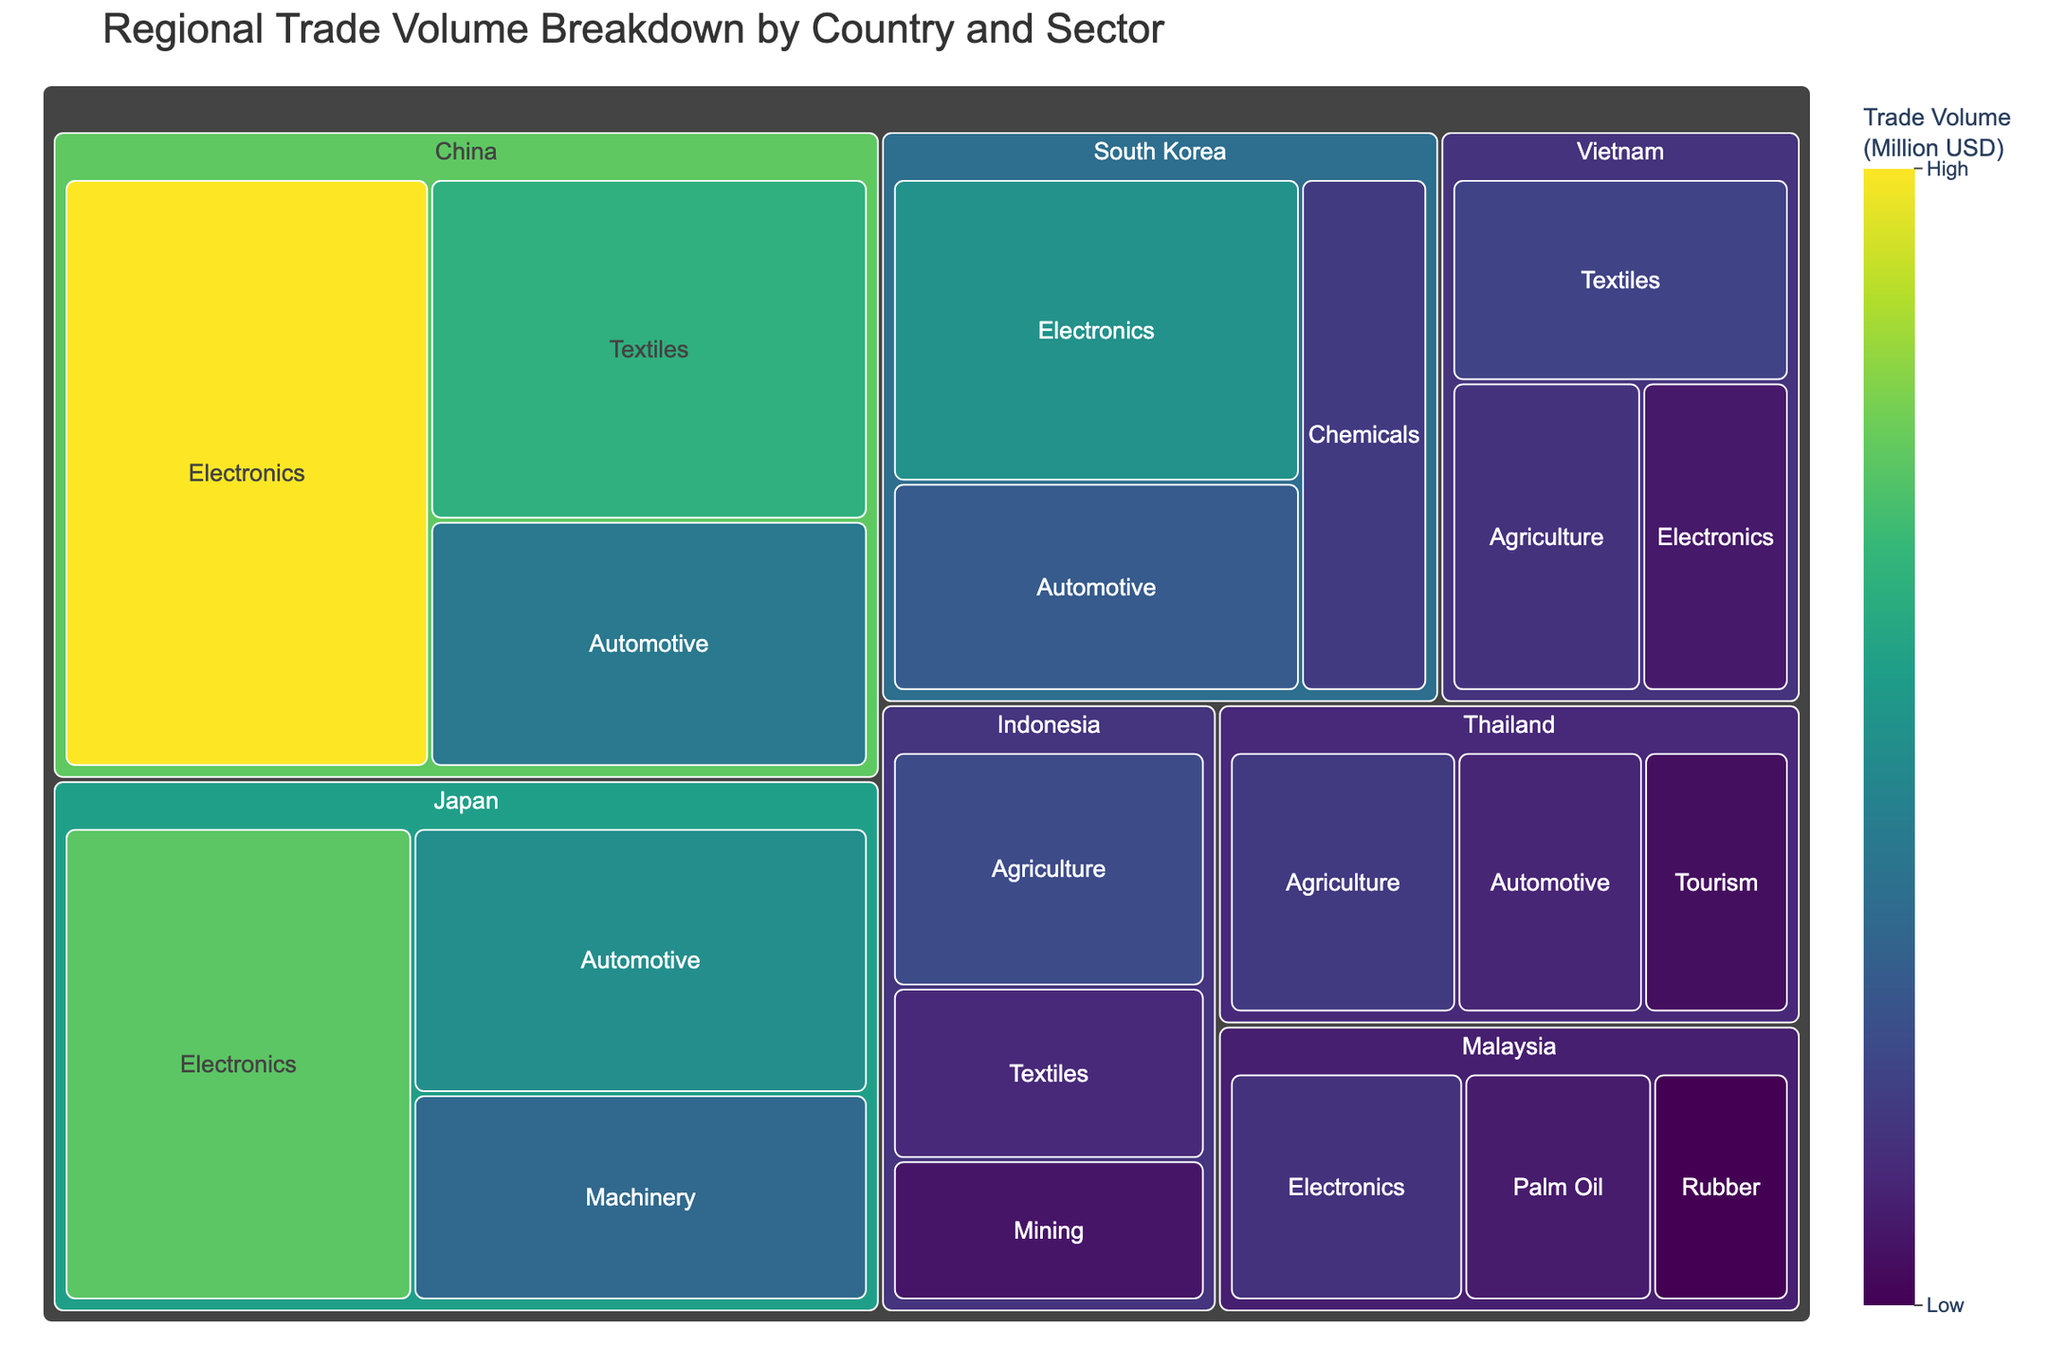what is the title of the figure? The title of the figure is usually placed at the top and clearly indicates the main subject. In this case, it reads "Regional Trade Volume Breakdown by Country and Sector".
Answer: Regional Trade Volume Breakdown by Country and Sector Which country has the highest trade volume in the Electronics sector? To determine this, look at the different segments under the Electronics category and identify the country with the largest segment. Here, China's Electronics sector has the highest trade volume.
Answer: China What is the total trade volume for Japan across all sectors? Sum the trade volumes for Japan's sectors: Electronics (9800) + Automotive (7200) + Machinery (5600). This gives a total trade volume.
Answer: 22600 Million USD Which sector has the smallest trade volume in Thailand? Look at all the sectors within Thailand's segments and compare their trade volumes. Tourism, with a volume of 2500 Million USD, is the smallest.
Answer: Tourism How does South Korea's trade volume in the Chemicals sector compare with Vietnam's trade volume in Textiles? Look at the trade volumes for both sectors: South Korea's Chemicals sector is 3900 Million USD and Vietnam's Textiles sector is 4200 Million USD. Vietnam's volume is higher.
Answer: Vietnam's volume is higher What is the difference in trade volume between China's Automotive sector and Japan's Automotive sector? Subtract Japan's Automotive trade volume (7200) from China's Automotive trade volume (6300).
Answer: -900 Million USD Which country contributes the least to the total trade volume in the Electronics sector, and what is their trade volume? Compare the trade volumes in the Electronics sector for all countries: Vietnam has the smallest contribution with 2800 Million USD.
Answer: Vietnam, 2800 Million USD Is there any sector where Malaysia has the highest trade volume compared to other countries in that sector? Compare Malaysia's trade volumes in each of its sectors to other countries' trade volumes in the same sectors. None of Malaysia's sectors have the highest trade volume compared to other countries.
Answer: No What is the average trade volume across all sectors for Vietnam? Sum Vietnam's trade volumes (Textiles 4200, Agriculture 3600, Electronics 2800) and divide by the number of sectors (3). The total is 10600, so the average is 10600/3.
Answer: 3533.33 Million USD Which country has the most diversified trade across different sectors? Look at the number of sectors listed for each country. Both China and Japan have 3 different sectors listed, but Japan's sectors are more evenly distributed in trade volume.
Answer: Japan 